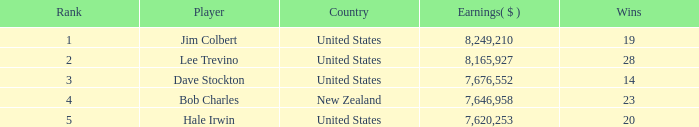How much have players made with 14 victories ranked below 3? 0.0. 